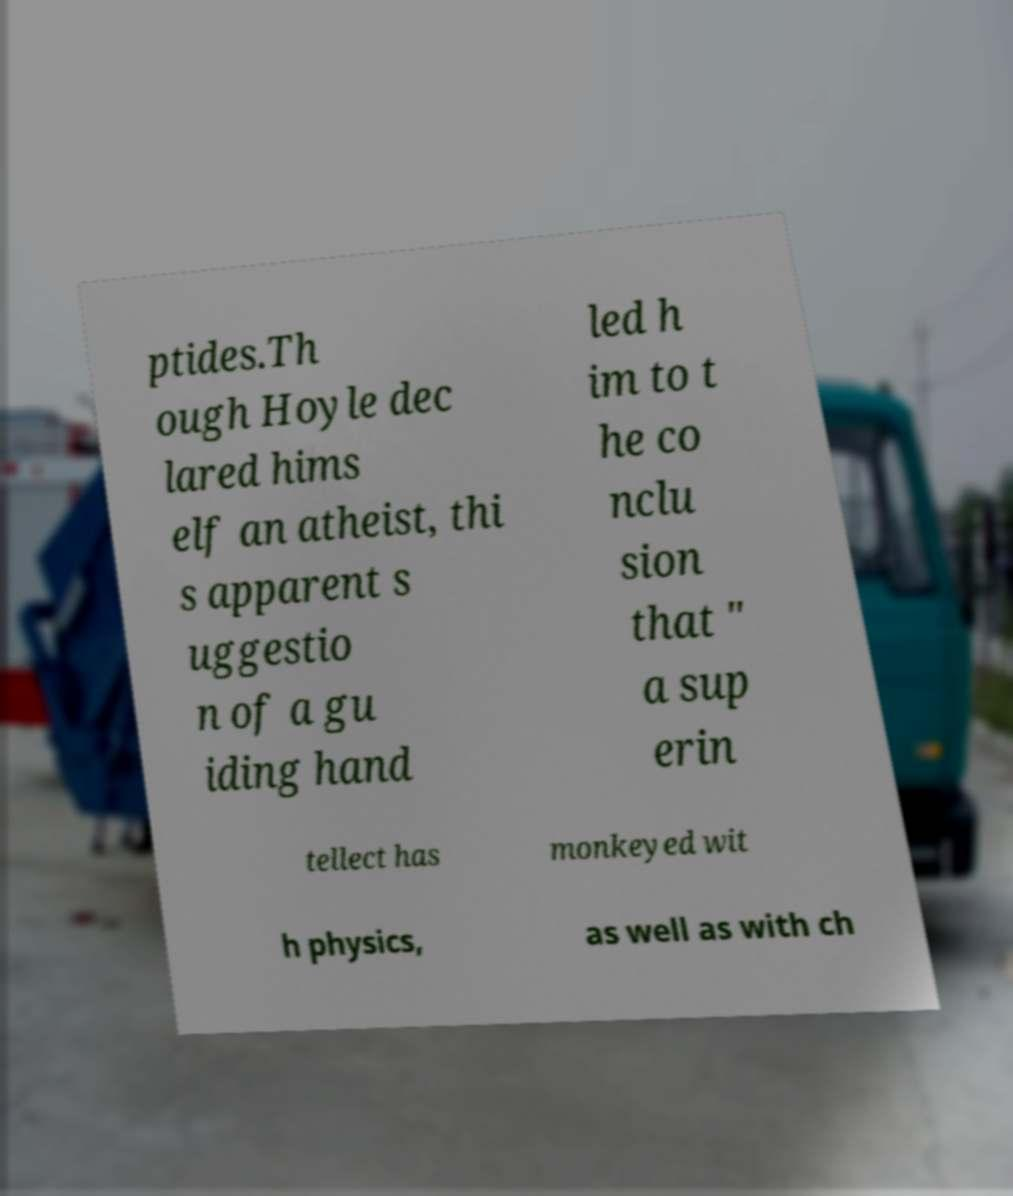Could you assist in decoding the text presented in this image and type it out clearly? ptides.Th ough Hoyle dec lared hims elf an atheist, thi s apparent s uggestio n of a gu iding hand led h im to t he co nclu sion that " a sup erin tellect has monkeyed wit h physics, as well as with ch 